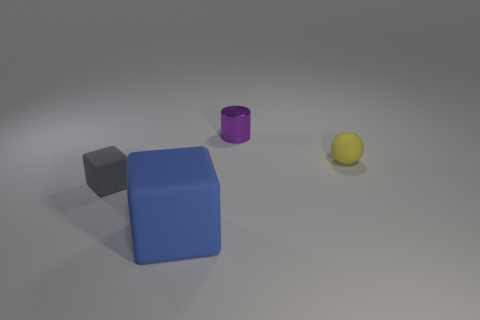Add 4 big blue matte objects. How many objects exist? 8 Subtract all cylinders. How many objects are left? 3 Add 2 red metal blocks. How many red metal blocks exist? 2 Subtract 1 gray blocks. How many objects are left? 3 Subtract all tiny shiny things. Subtract all purple objects. How many objects are left? 2 Add 4 tiny purple cylinders. How many tiny purple cylinders are left? 5 